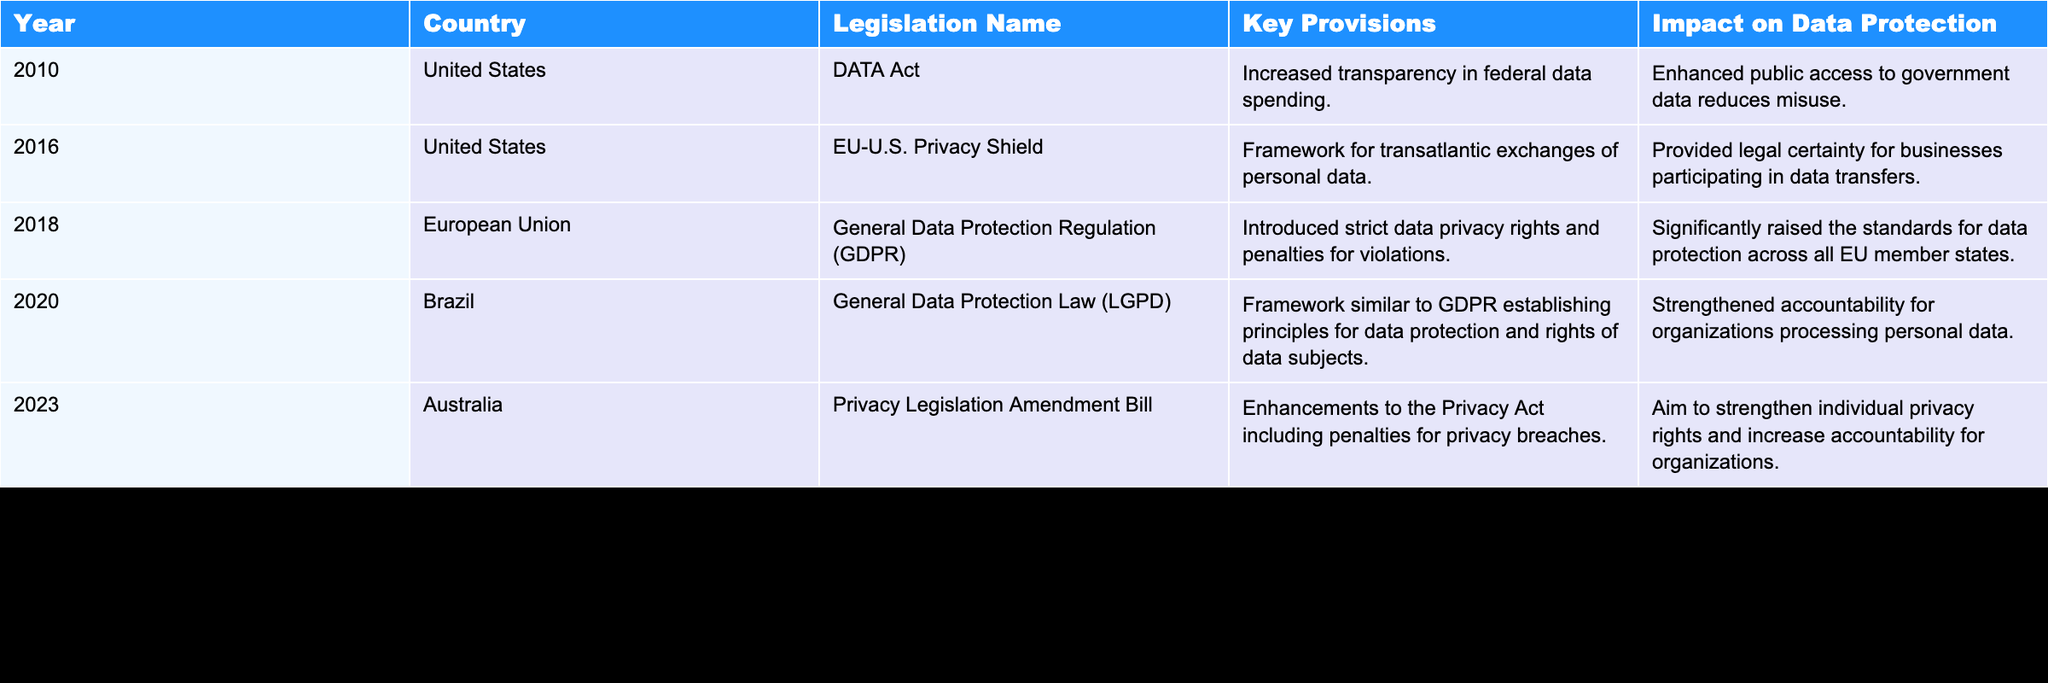What legislation was enacted in the European Union in 2018? The table shows that the "General Data Protection Regulation (GDPR)" was enacted in the European Union in 2018.
Answer: General Data Protection Regulation (GDPR) Which country enacted data protection legislation in 2020? The data reveals that Brazil enacted the "General Data Protection Law (LGPD)" in 2020.
Answer: Brazil What is the key provision of the Privacy Legislation Amendment Bill from Australia in 2023? The key provision listed for Australia's Privacy Legislation Amendment Bill in 2023 is enhancements to the Privacy Act including penalties for privacy breaches.
Answer: Enhancements to the Privacy Act including penalties for privacy breaches Did the United States enact any legislation related to data protection in 2016? Yes, the United States enacted the "EU-U.S. Privacy Shield" in 2016, as indicated in the table.
Answer: Yes Which legislation had the most significant impact on data protection according to the table? The table indicates that the GDPR significantly raised the standards for data protection across all EU member states, suggesting it had a profound impact.
Answer: General Data Protection Regulation (GDPR) What was the year of enactment for the DATA Act in the United States? According to the table, the DATA Act was enacted in the year 2010.
Answer: 2010 List the key provisions of the General Data Protection Law (LGPD) passed in Brazil. The key provisions of the LGPD include establishing principles for data protection and rights of data subjects, as stated in the table.
Answer: Establishing principles for data protection and rights of data subjects How many pieces of legislation were enacted between 2010 and 2023 according to the table? By counting the entries in the table, we find that there are five pieces of legislation enacted between 2010 and 2023.
Answer: 5 Which country's legislation aimed to strengthen individual privacy rights and increase accountability for organizations? The table indicates that Australia's Privacy Legislation Amendment Bill from 2023 aimed to strengthen individual privacy rights and increase accountability.
Answer: Australia 